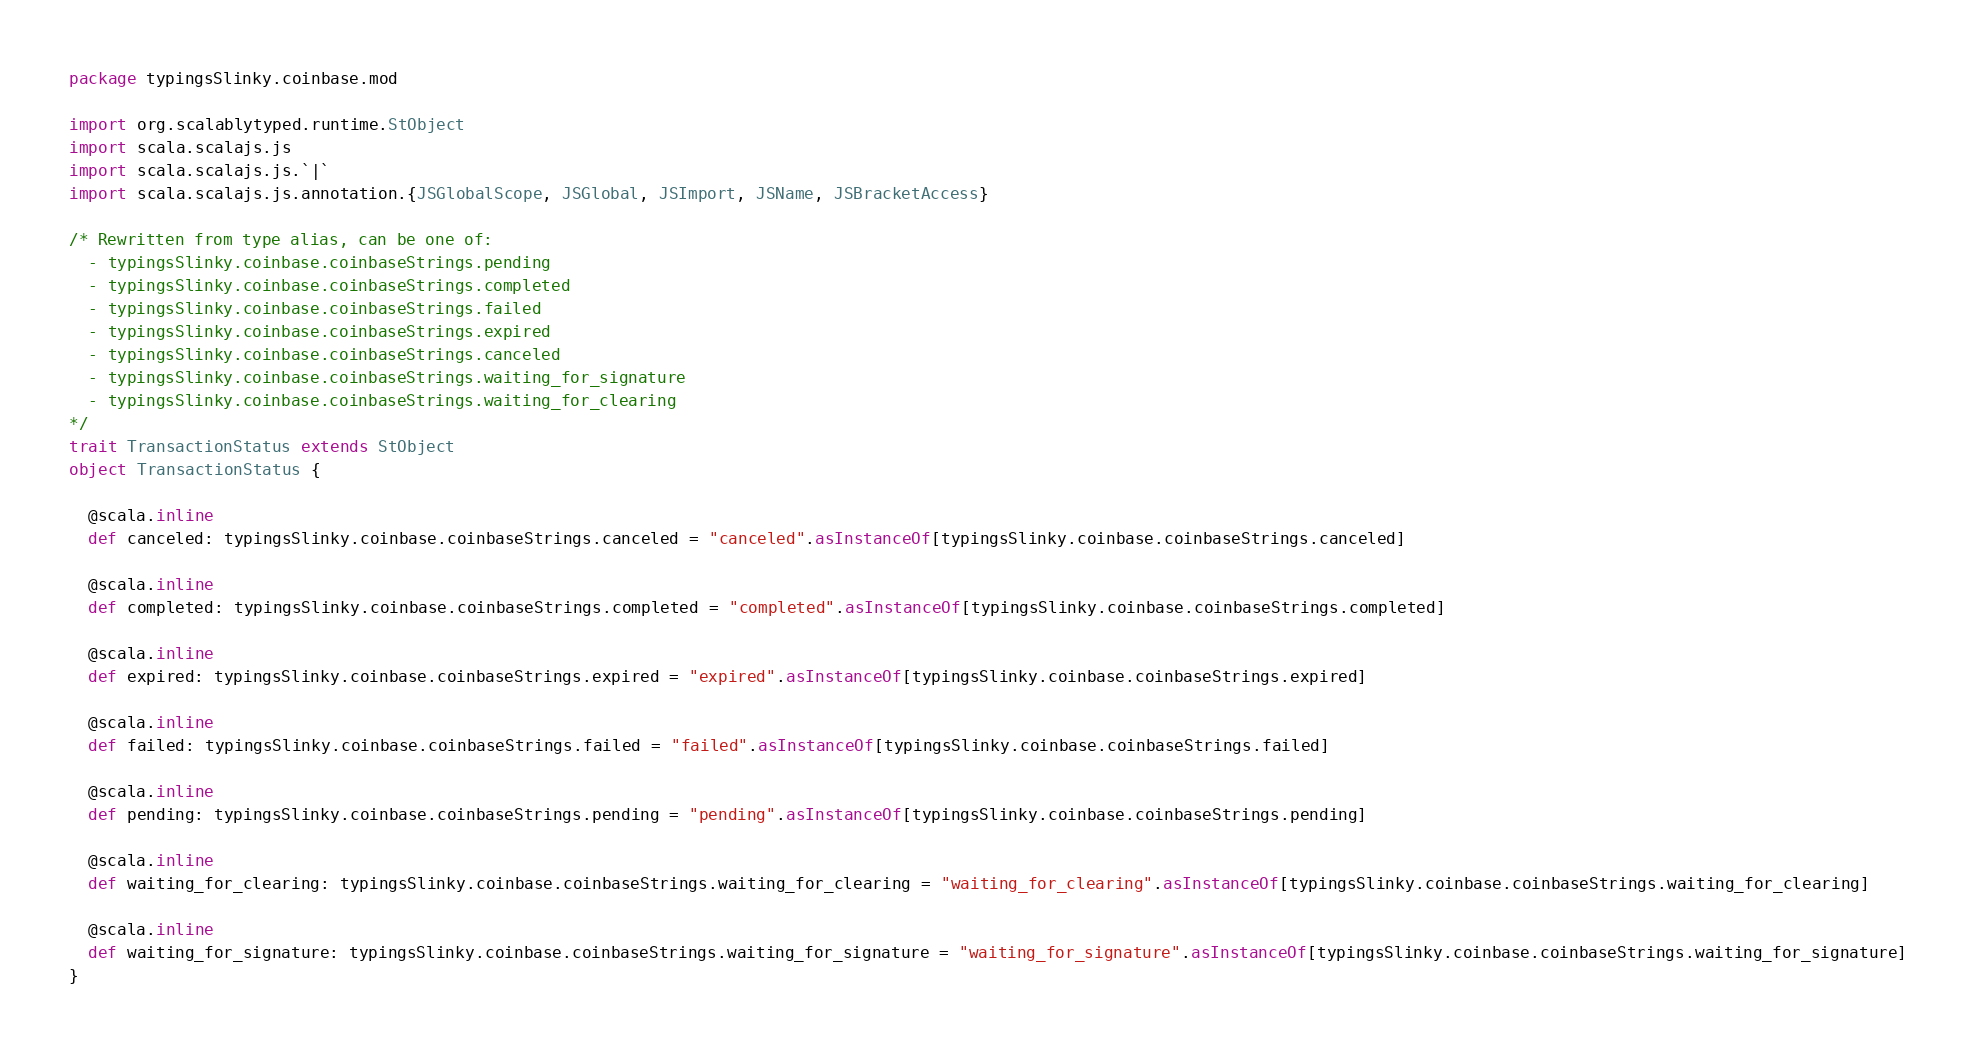Convert code to text. <code><loc_0><loc_0><loc_500><loc_500><_Scala_>package typingsSlinky.coinbase.mod

import org.scalablytyped.runtime.StObject
import scala.scalajs.js
import scala.scalajs.js.`|`
import scala.scalajs.js.annotation.{JSGlobalScope, JSGlobal, JSImport, JSName, JSBracketAccess}

/* Rewritten from type alias, can be one of: 
  - typingsSlinky.coinbase.coinbaseStrings.pending
  - typingsSlinky.coinbase.coinbaseStrings.completed
  - typingsSlinky.coinbase.coinbaseStrings.failed
  - typingsSlinky.coinbase.coinbaseStrings.expired
  - typingsSlinky.coinbase.coinbaseStrings.canceled
  - typingsSlinky.coinbase.coinbaseStrings.waiting_for_signature
  - typingsSlinky.coinbase.coinbaseStrings.waiting_for_clearing
*/
trait TransactionStatus extends StObject
object TransactionStatus {
  
  @scala.inline
  def canceled: typingsSlinky.coinbase.coinbaseStrings.canceled = "canceled".asInstanceOf[typingsSlinky.coinbase.coinbaseStrings.canceled]
  
  @scala.inline
  def completed: typingsSlinky.coinbase.coinbaseStrings.completed = "completed".asInstanceOf[typingsSlinky.coinbase.coinbaseStrings.completed]
  
  @scala.inline
  def expired: typingsSlinky.coinbase.coinbaseStrings.expired = "expired".asInstanceOf[typingsSlinky.coinbase.coinbaseStrings.expired]
  
  @scala.inline
  def failed: typingsSlinky.coinbase.coinbaseStrings.failed = "failed".asInstanceOf[typingsSlinky.coinbase.coinbaseStrings.failed]
  
  @scala.inline
  def pending: typingsSlinky.coinbase.coinbaseStrings.pending = "pending".asInstanceOf[typingsSlinky.coinbase.coinbaseStrings.pending]
  
  @scala.inline
  def waiting_for_clearing: typingsSlinky.coinbase.coinbaseStrings.waiting_for_clearing = "waiting_for_clearing".asInstanceOf[typingsSlinky.coinbase.coinbaseStrings.waiting_for_clearing]
  
  @scala.inline
  def waiting_for_signature: typingsSlinky.coinbase.coinbaseStrings.waiting_for_signature = "waiting_for_signature".asInstanceOf[typingsSlinky.coinbase.coinbaseStrings.waiting_for_signature]
}
</code> 